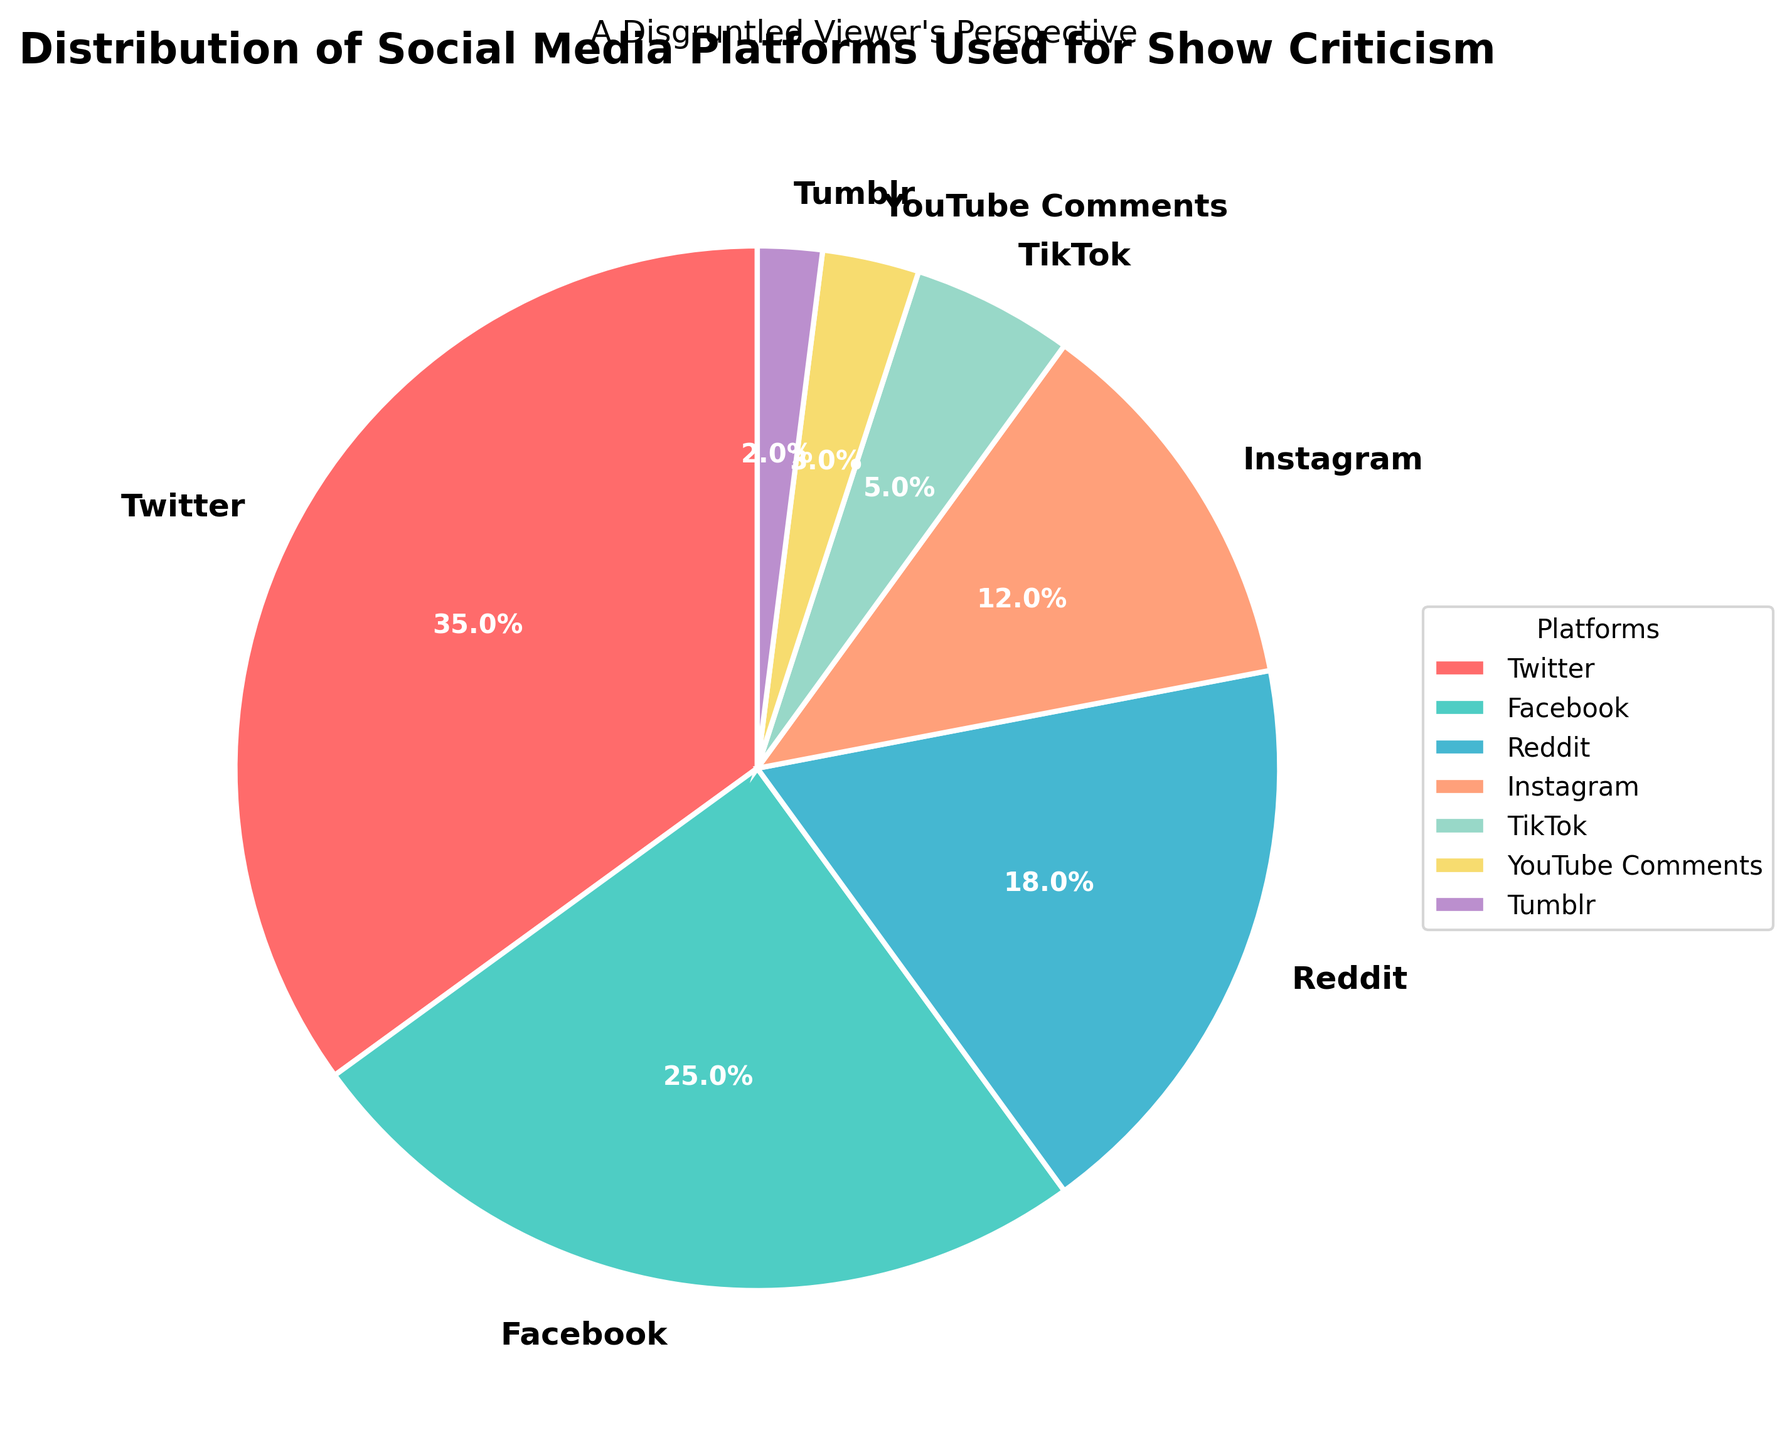Which platform is used the most for show criticism? The pie chart indicates that the platform with the largest percentage is Twitter at 35%
Answer: Twitter Which platform is used the least for show criticism? The pie chart shows that the platform with the smallest percentage is Tumblr at 2%
Answer: Tumblr What is the combined percentage of criticism on Twitter and Facebook? Adding the percentages of Twitter and Facebook: 35% + 25% = 60%
Answer: 60% Is the percentage of criticisms on Instagram greater than on TikTok? The pie chart shows Instagram's percentage is 12% and TikTok's is 5%; 12% is greater than 5%
Answer: Yes What is the difference in percentage between Reddit and Facebook? Subtracting Reddit's percentage from Facebook's: 25% - 18% = 7%
Answer: 7% What percentage of criticisms come from YouTube Comments and Tumblr combined? Adding the percentages of YouTube Comments and Tumblr: 3% + 2% = 5%
Answer: 5% Which platform has a percentage closest to Reddit's? Comparing other platforms' percentages, Instagram at 12% is closest to Reddit's 18%
Answer: Instagram Are the combined percentage of criticisms on Instagram and TikTok higher than that on Facebook alone? Adding Instagram's and TikTok's percentages: 12% + 5% = 17%; comparing with Facebook's 25%, 17% is less than 25%
Answer: No What is the difference between the platform with the highest percentage and the platform with the lowest percentage? Subtracting Tumblr's 2% from Twitter's 35%: 35% - 2% = 33%
Answer: 33% How much more critical is Reddit compared to YouTube Comments? Subtracting YouTube Comments' percentage from Reddit's: 18% - 3% = 15%
Answer: 15% 